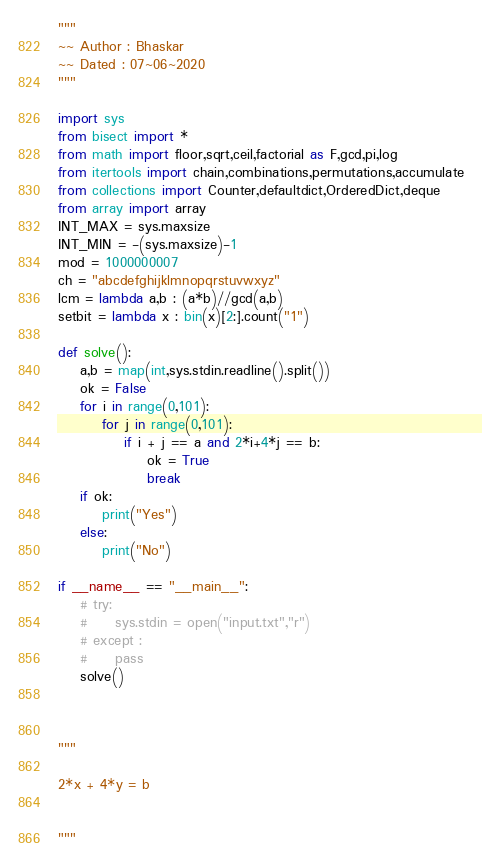<code> <loc_0><loc_0><loc_500><loc_500><_Python_>"""
~~ Author : Bhaskar
~~ Dated : 07~06~2020
"""

import sys
from bisect import *
from math import floor,sqrt,ceil,factorial as F,gcd,pi,log
from itertools import chain,combinations,permutations,accumulate
from collections import Counter,defaultdict,OrderedDict,deque
from array import array
INT_MAX = sys.maxsize
INT_MIN = -(sys.maxsize)-1
mod = 1000000007
ch = "abcdefghijklmnopqrstuvwxyz"
lcm = lambda a,b : (a*b)//gcd(a,b)
setbit = lambda x : bin(x)[2:].count("1")

def solve():
    a,b = map(int,sys.stdin.readline().split())
    ok = False
    for i in range(0,101):
        for j in range(0,101):
            if i + j == a and 2*i+4*j == b:
                ok = True
                break
    if ok:
        print("Yes")
    else:
        print("No")

if __name__ == "__main__":
    # try:
    #     sys.stdin = open("input.txt","r")
    # except :
    #     pass
    solve()



"""

2*x + 4*y = b


"""
</code> 